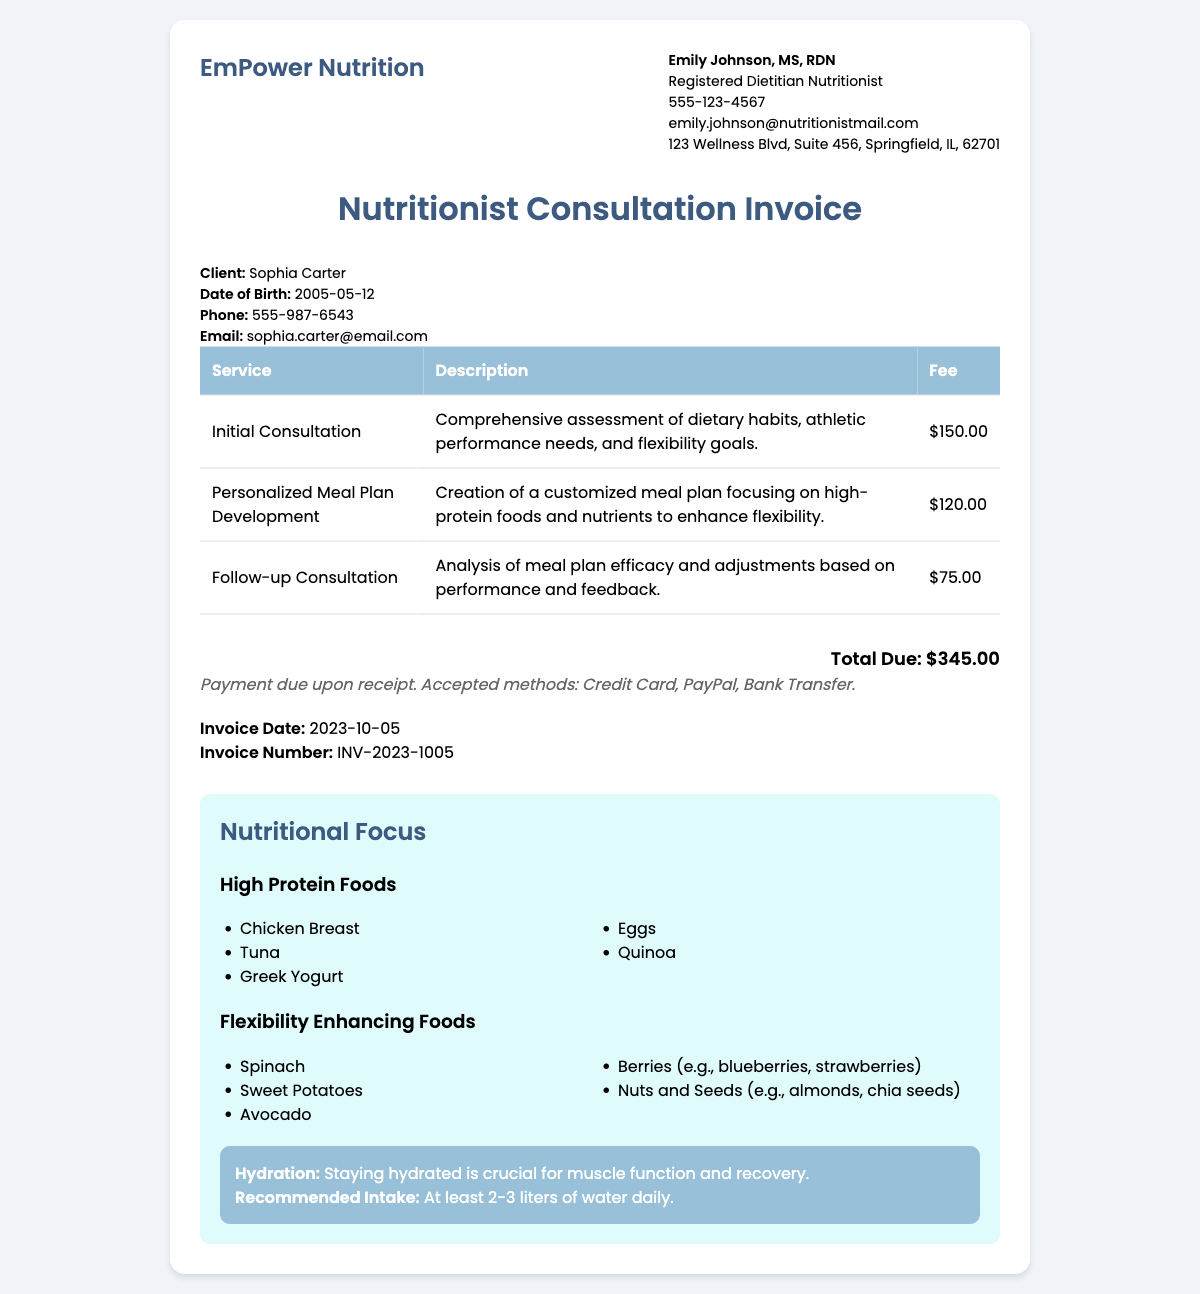What is the name of the nutritionist? The name of the nutritionist is listed in the consultant info section of the document.
Answer: Emily Johnson, MS, RDN What is the total fee for services? The total fee is indicated at the bottom of the invoice as the sum of all service fees.
Answer: $345.00 What is the invoice date? The invoice date is specified in the document under the invoice details.
Answer: 2023-10-05 How much does the follow-up consultation cost? The cost of the follow-up consultation is provided in the table detailing services.
Answer: $75.00 What food is listed as a high-protein option? The document lists various high-protein foods which are highlighted in the nutritional focus section.
Answer: Chicken Breast What is the recommended daily water intake? The hydration section of the document specifies the recommended intake for hydration.
Answer: At least 2-3 liters What is the purpose of the initial consultation? The description for the initial consultation explains its objective in the services table.
Answer: Comprehensive assessment of dietary habits, athletic performance needs, and flexibility goals What payment methods are accepted? The payment terms section details the accepted payment methods for the invoice.
Answer: Credit Card, PayPal, Bank Transfer 